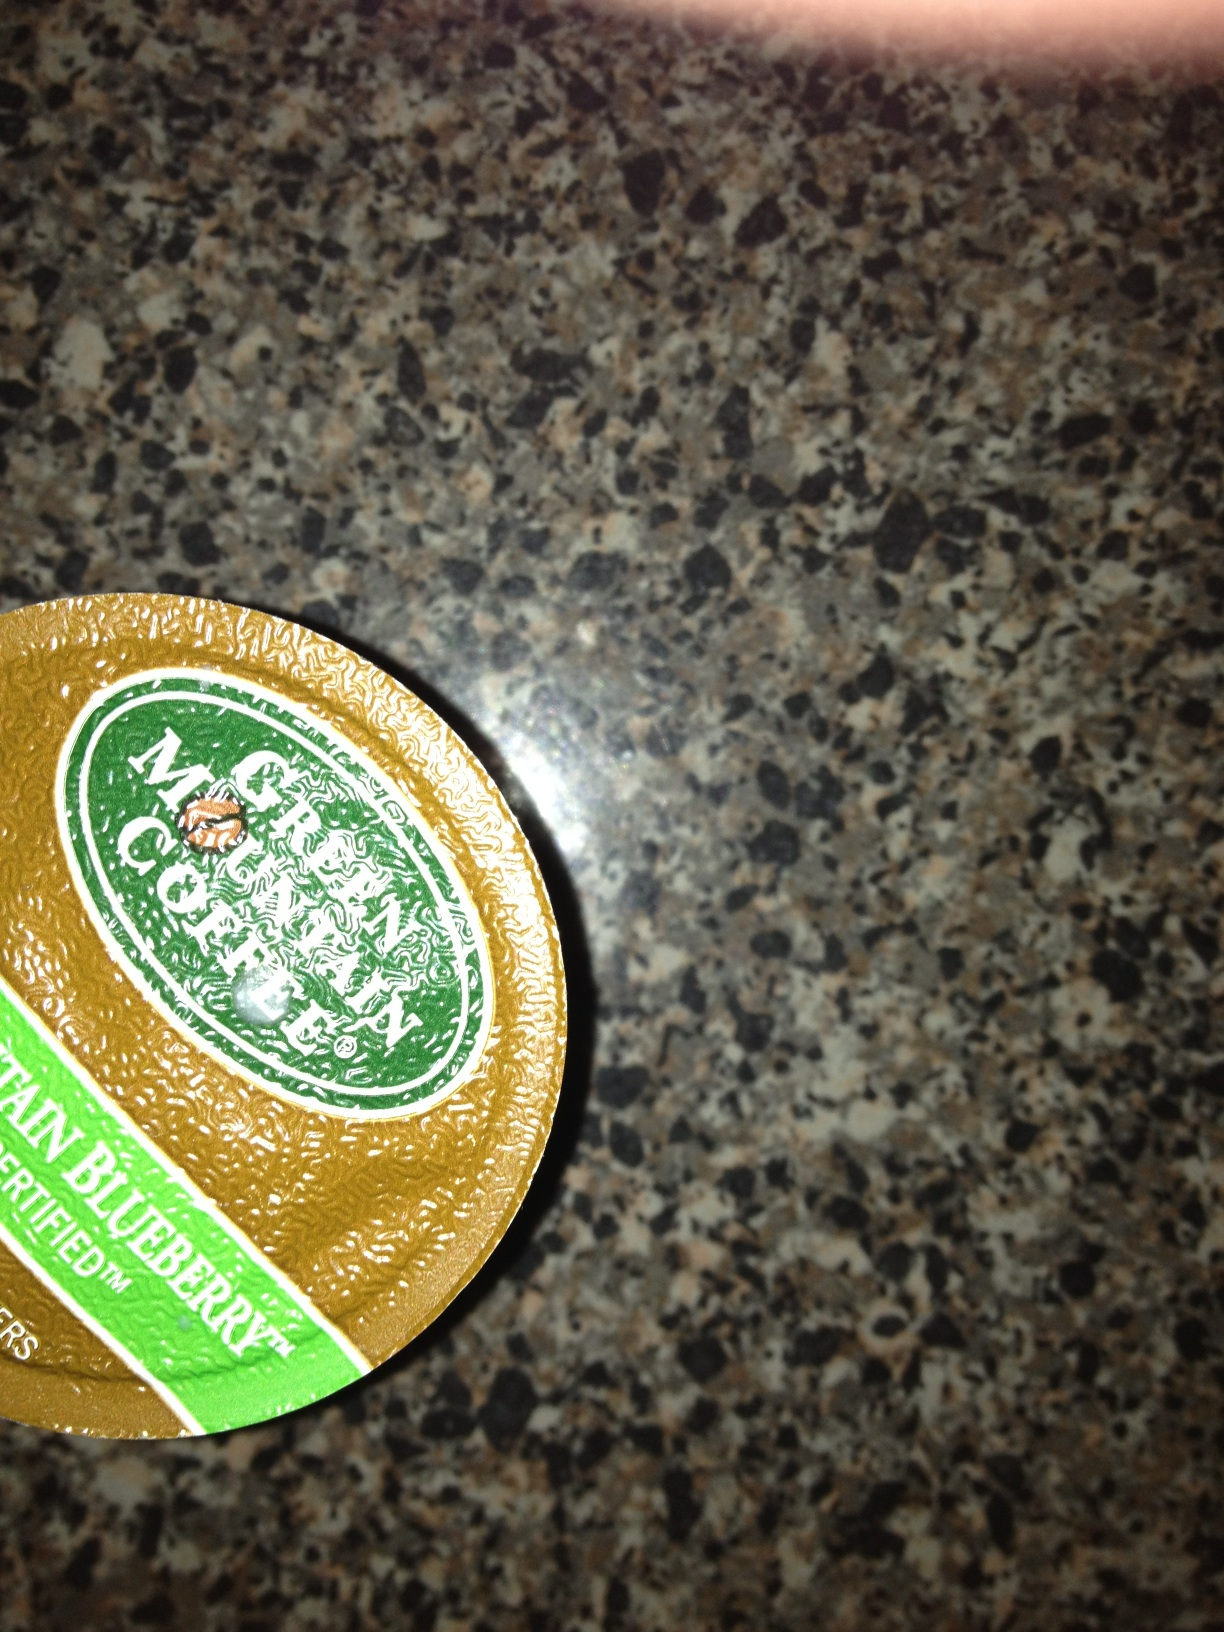What flavors of coffee does Green Mountain Coffee Roasters offer? Green Mountain Coffee Roasters offers a wide variety of coffee flavors, ranging from seasonal specialties to classic choices. Some popular flavors include Breakfast Blend, French Roast, and a variety of seasonal favorites like Pumpkin Spice and Spicy Eggnog. Additionally, there are unique flavors like the Mountain Blueberry shown in the image, offering a fresh and fruity coffee experience. Can you suggest a creative recipe using the Mountain Blueberry coffee? Certainly! Here's a creative recipe for a Mountain Blueberry Coffee Smoothie:

Ingredients:
- 1 cup of brewed and chilled Mountain Blueberry coffee
- 1/2 cup of frozen blueberries
- 1 banana
- 1/2 cup of vanilla Greek yogurt
- 1 tablespoon of honey
- Ice cubes (optional)

Instructions:
1. Brew a cup of Mountain Blueberry coffee and let it cool completely.
2. In a blender, add the chilled coffee, frozen blueberries, banana, Greek yogurt, and honey.
3. Blend until smooth and creamy. If you prefer a thicker smoothie, add a few ice cubes and blend again.
4. Pour into a glass and enjoy your refreshing Mountain Blueberry Coffee Smoothie! 